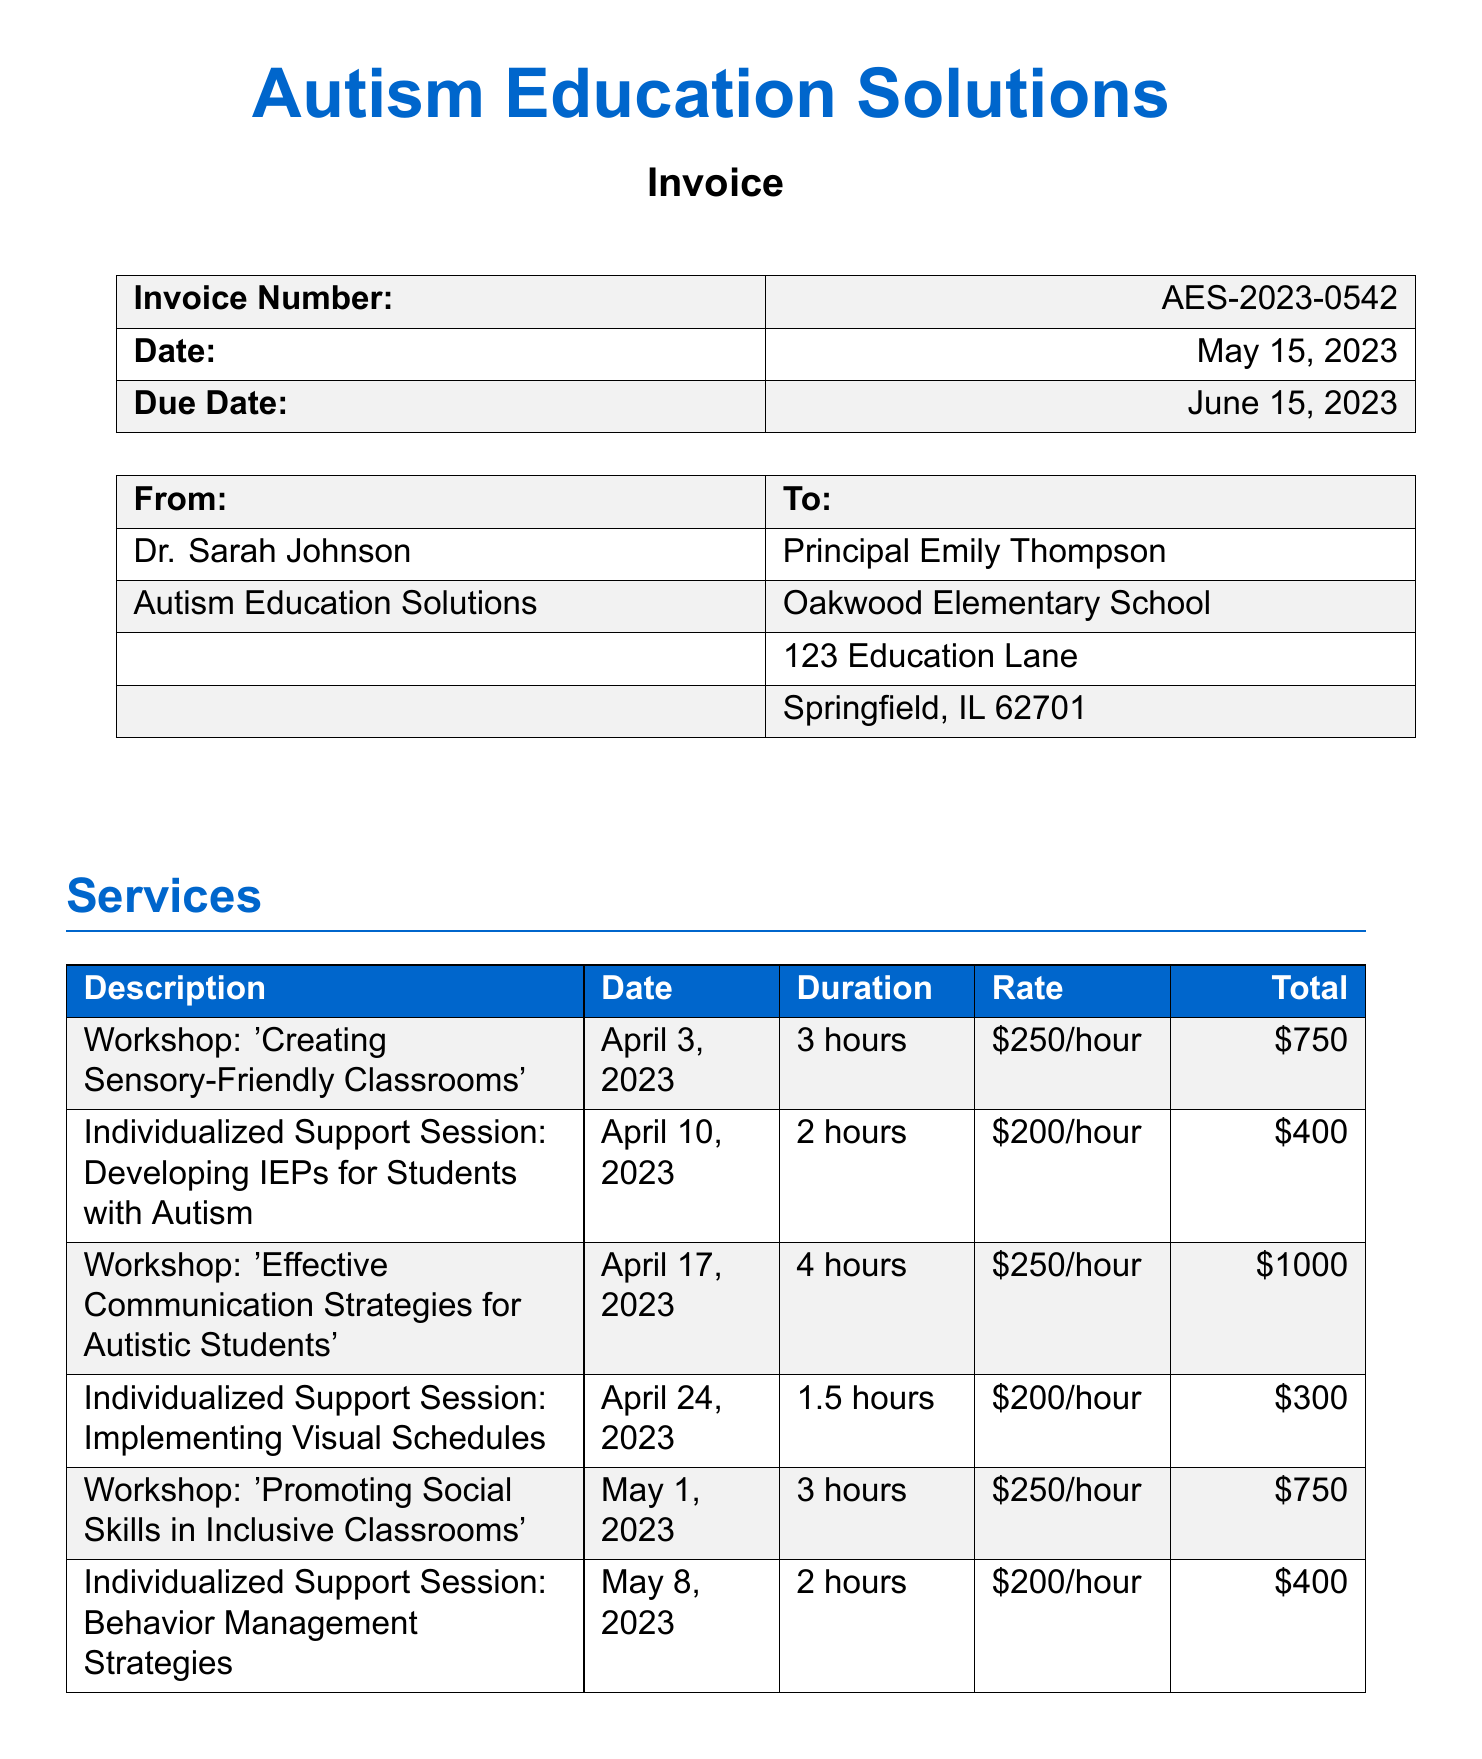What is the name of the consultant? The consultant's name is listed at the top of the invoice under the consultant details.
Answer: Dr. Sarah Johnson What is the total amount due? The total amount due is provided in the payment details section of the invoice.
Answer: $4159.69 When is the invoice due date? The due date is specified within the invoice details section.
Answer: June 15, 2023 What is the tax rate applied to the invoice? The tax rate is mentioned in the payment details section.
Answer: 8.75% How many workshops were conducted? The number of workshops can be counted in the services section of the invoice.
Answer: 3 What is the subtotal before tax? The subtotal is clearly stated in the payment details section and is calculated before any tax is added.
Answer: $3825 What type of payment methods are accepted? The payment methods section outlines how payments can be made.
Answer: Check, electronic What is the date of the workshop titled 'Effective Communication Strategies for Autistic Students'? The date of the workshop is mentioned in the services section along with its description.
Answer: April 17, 2023 What was the total cost for individualized support sessions? The total cost can be calculated using the provided totals for all individualized support sessions in the services section.
Answer: $700 